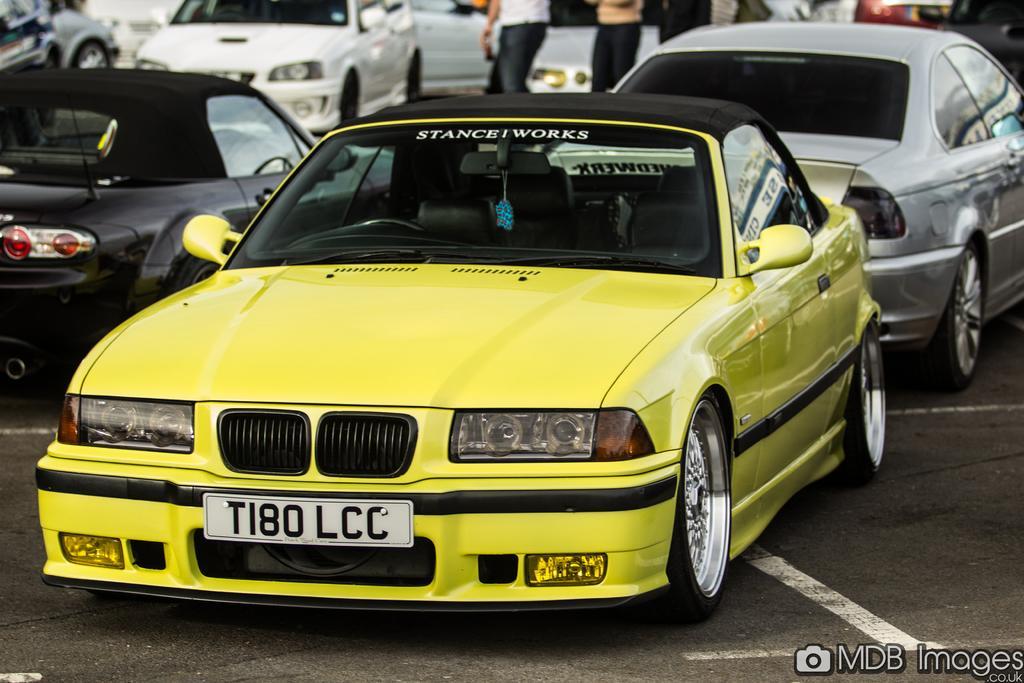Describe this image in one or two sentences. In this picture there is a yellow color car in the center of the image and there are other cars in the background area of the image and there are people at the top side of the image. 